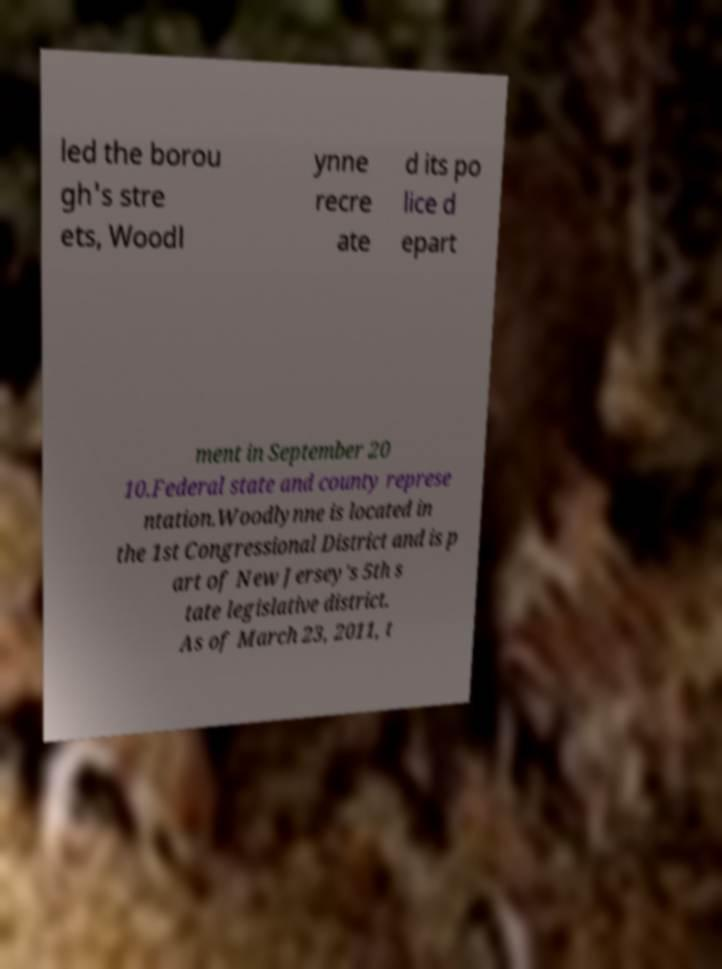Can you read and provide the text displayed in the image?This photo seems to have some interesting text. Can you extract and type it out for me? led the borou gh's stre ets, Woodl ynne recre ate d its po lice d epart ment in September 20 10.Federal state and county represe ntation.Woodlynne is located in the 1st Congressional District and is p art of New Jersey's 5th s tate legislative district. As of March 23, 2011, t 